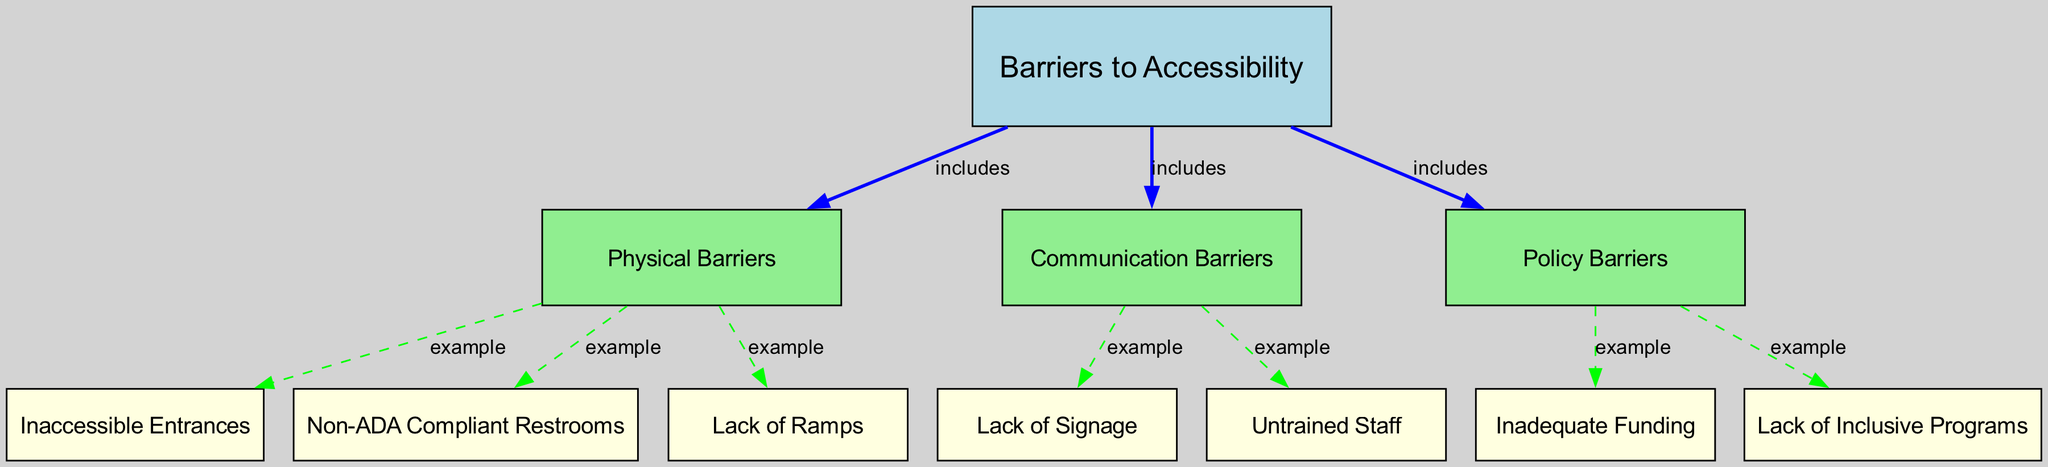What are the main categories of barriers to accessibility? The diagram lists three main categories under the topic "Barriers to Accessibility": Physical Barriers, Communication Barriers, and Policy Barriers. These categories group the specific issues that individuals with spinal cord injuries face in accessing sports facilities.
Answer: Physical Barriers, Communication Barriers, Policy Barriers How many issues fall under Physical Barriers? From the diagram, under the main category of Physical Barriers, there are three specific issues listed: Inaccessible Entrances, Non-ADA Compliant Restrooms, and Lack of Ramps. Counting these gives a total of three issues.
Answer: 3 Which issue is an example of a Communication Barrier? The diagram shows that Lack of Signage is connected under Communication Barriers as an example. This indicates that it is classified as a communication barrier that affects accessibility.
Answer: Lack of Signage What is an example of a Policy Barrier? The diagram indicates two examples under Policy Barriers: Inadequate Funding and Lack of Inclusive Programs. These issues demonstrate the challenges faced in terms of policies that hinder accessibility.
Answer: Inadequate Funding, Lack of Inclusive Programs How many nodes are classified as ‘issues’ in total? The diagram depicts a total of eight issues across all categories: three under Physical Barriers, two under Communication Barriers, and two under Policy Barriers. Counting these gives a total of eight issues classified as examples.
Answer: 8 What is the connection type between "Barriers to Accessibility" and "Physical Barriers"? The connection type between "Barriers to Accessibility" and "Physical Barriers" in the diagram is labeled 'includes.' This indicates that Physical Barriers is a subset of the overarching topic concerning accessibility.
Answer: includes Which category includes the example "Untrained Staff"? The example "Untrained Staff" is found under the category of Communication Barriers. This shows that one of the communication-related issues affecting accessibility relates to the training of staff members.
Answer: Communication Barriers Name a specific issue listed under the category of Policy Barriers. Under the Policy Barriers category, a specific issue listed is "Inadequate Funding". This reflects a challenge related to the policies affecting accessibility in sports.
Answer: Inadequate Funding 